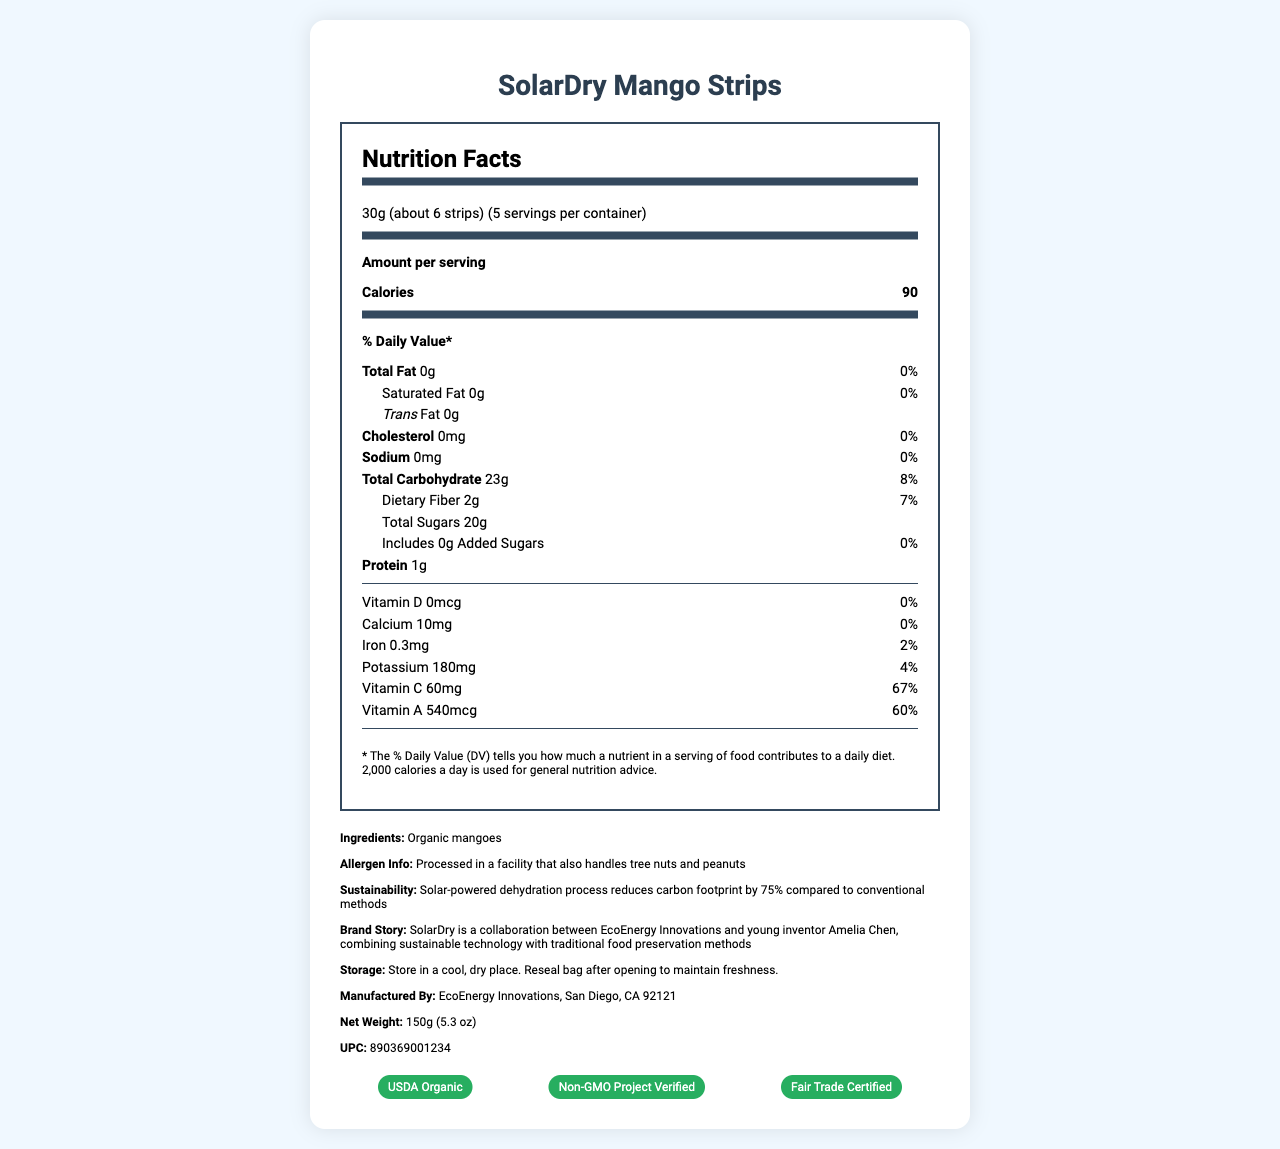what is the serving size of SolarDry Mango Strips? The serving size is clearly indicated in the nutrition facts as "30g (about 6 strips)".
Answer: 30g (about 6 strips) how many calories are in one serving of SolarDry Mango Strips? The nutrition facts list the calories per serving as 90.
Answer: 90 what is the amount of total fat per serving? The document shows that the total fat per serving is 0g, along with a percent daily value of 0%.
Answer: 0g what is the protein content per serving? According to the nutrition facts, the protein content per serving is 1g.
Answer: 1g what is the percent daily value of Vitamin C in one serving? The nutrition facts state that the percent daily value of Vitamin C is 67%.
Answer: 67% which certifications does SolarDry Mango Strips have? A. USDA Organic B. Non-GMO Project Verified C. Fair Trade Certified D. All of the above The certifications listed in the document include USDA Organic, Non-GMO Project Verified, and Fair Trade Certified.
Answer: D which of the following nutrients has the highest percent daily value? I. Vitamin A II. Vitamin C III. Iron Vitamin A has a percent daily value of 60%, Vitamin C has 67%, and Iron has 2%. Therefore, Vitamin C has the highest percent daily value.
Answer: II is there any added sugar in SolarDry Mango Strips? The nutrition facts state that added sugars are 0g per serving.
Answer: No describe the main idea of this document. The document includes a comprehensive overview of the nutritional content, product details, and unique selling points of SolarDry Mango Strips, emphasizing sustainability and health benefits.
Answer: The document provides a detailed nutrition facts label for SolarDry Mango Strips, a snack made from organic mangoes dehydrated using a solar-powered process. It includes information on serving size, calories, various nutrients, and additional product details such as ingredients, allergen information, sustainability efforts, certifications, and storage instructions. where was the SolarDry Mango Strips product manufactured? The document mentions that the product is manufactured by EcoEnergy Innovations in San Diego, CA 92121.
Answer: San Diego, CA 92121 what is the net weight of the product? The document specifies the net weight as 150g (5.3 oz).
Answer: 150g (5.3 oz) how does the solar-powered dehydration process benefit the environment? This information is stated in the sustainability section of the document.
Answer: The solar-powered dehydration process reduces the carbon footprint by 75% compared to conventional methods. who is the young inventor mentioned in the brand story? The brand story mentions that SolarDry is a collaboration between EcoEnergy Innovations and young inventor Amelia Chen.
Answer: Amelia Chen how many servings are contained in one package of SolarDry Mango Strips? The serving information states that there are 5 servings per container.
Answer: 5 does the product contain any common allergens? The allergen information mentions that the product is processed in a facility that also handles tree nuts and peanuts.
Answer: Yes what is the barcode (UPC) for SolarDry Mango Strips? The document lists the barcode UPC as 890369001234.
Answer: 890369001234 what is the production cost of SolarDry Mango Strips? The document does not provide any information regarding the production cost of the product.
Answer: Cannot be determined what element is present in a quantity of 180mg per serving? The nutrition facts show that potassium content per serving is 180mg.
Answer: Potassium 